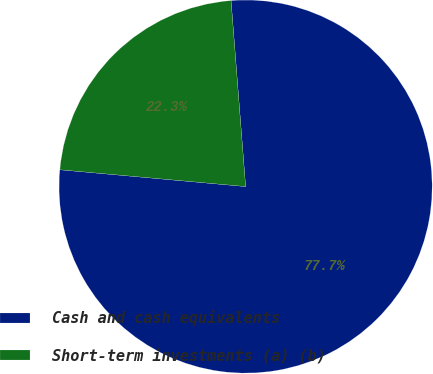<chart> <loc_0><loc_0><loc_500><loc_500><pie_chart><fcel>Cash and cash equivalents<fcel>Short-term investments (a) (b)<nl><fcel>77.68%<fcel>22.32%<nl></chart> 